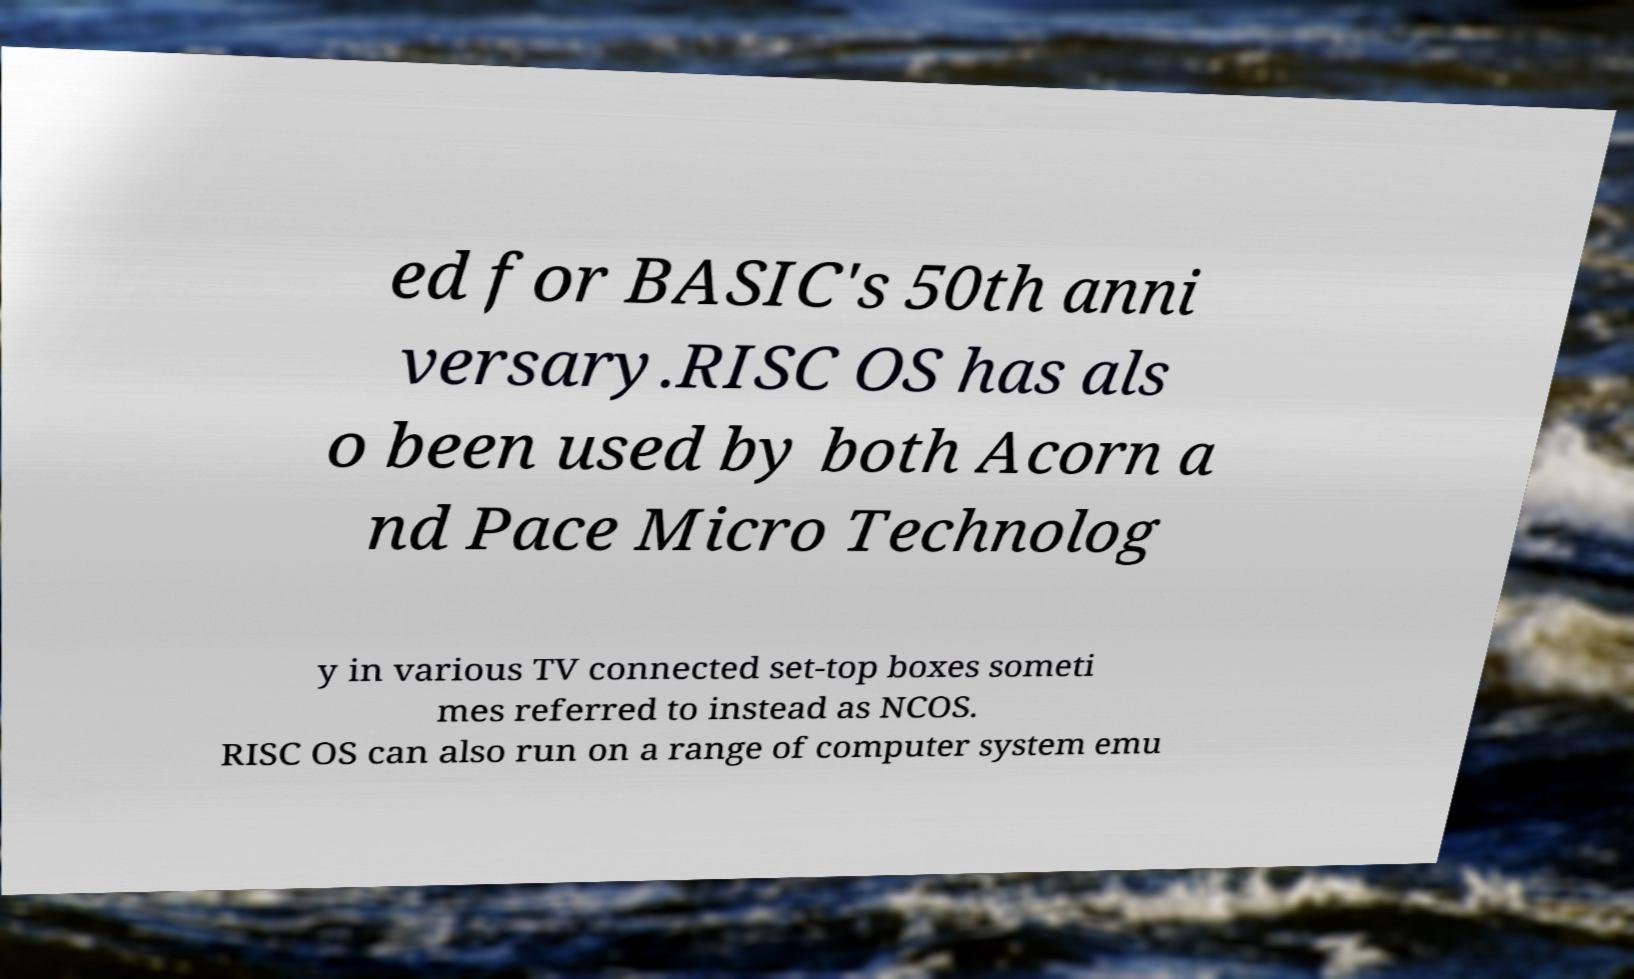For documentation purposes, I need the text within this image transcribed. Could you provide that? ed for BASIC's 50th anni versary.RISC OS has als o been used by both Acorn a nd Pace Micro Technolog y in various TV connected set-top boxes someti mes referred to instead as NCOS. RISC OS can also run on a range of computer system emu 